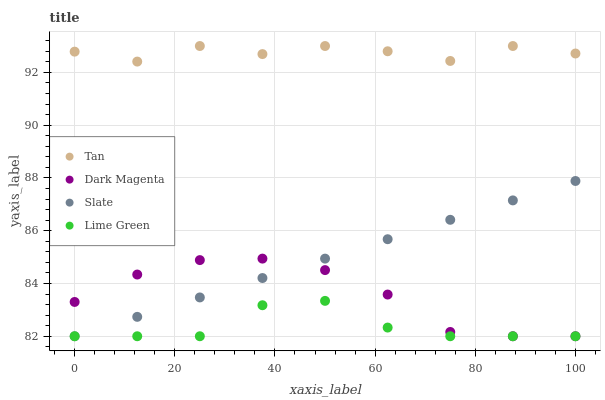Does Lime Green have the minimum area under the curve?
Answer yes or no. Yes. Does Tan have the maximum area under the curve?
Answer yes or no. Yes. Does Slate have the minimum area under the curve?
Answer yes or no. No. Does Slate have the maximum area under the curve?
Answer yes or no. No. Is Slate the smoothest?
Answer yes or no. Yes. Is Tan the roughest?
Answer yes or no. Yes. Is Lime Green the smoothest?
Answer yes or no. No. Is Lime Green the roughest?
Answer yes or no. No. Does Slate have the lowest value?
Answer yes or no. Yes. Does Tan have the highest value?
Answer yes or no. Yes. Does Slate have the highest value?
Answer yes or no. No. Is Dark Magenta less than Tan?
Answer yes or no. Yes. Is Tan greater than Dark Magenta?
Answer yes or no. Yes. Does Dark Magenta intersect Slate?
Answer yes or no. Yes. Is Dark Magenta less than Slate?
Answer yes or no. No. Is Dark Magenta greater than Slate?
Answer yes or no. No. Does Dark Magenta intersect Tan?
Answer yes or no. No. 